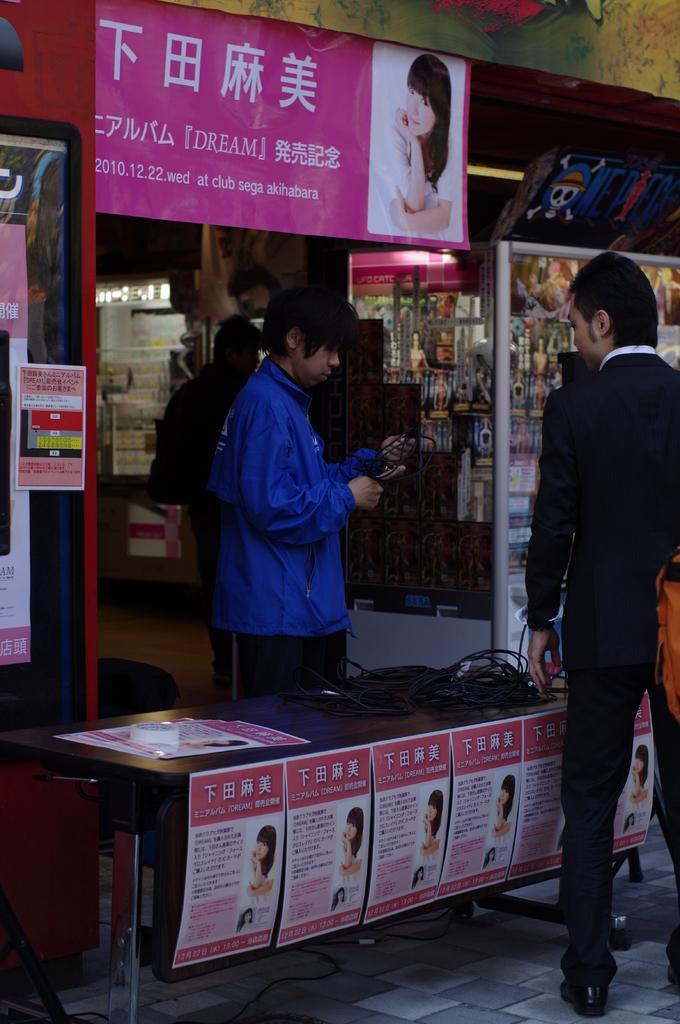Could you give a brief overview of what you see in this image? In this image, we can see a shop, we can see three persons standing. There are some posters pasted. 